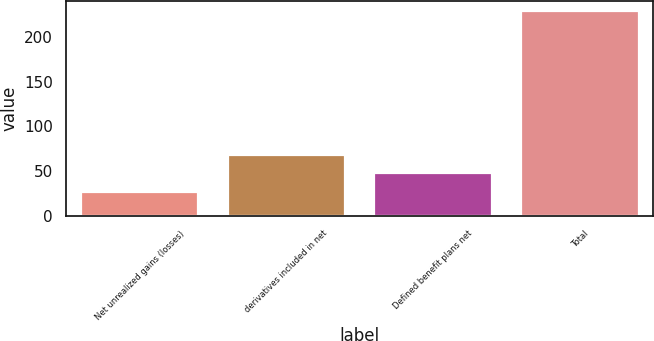<chart> <loc_0><loc_0><loc_500><loc_500><bar_chart><fcel>Net unrealized gains (losses)<fcel>derivatives included in net<fcel>Defined benefit plans net<fcel>Total<nl><fcel>26<fcel>67.8<fcel>48<fcel>228.8<nl></chart> 